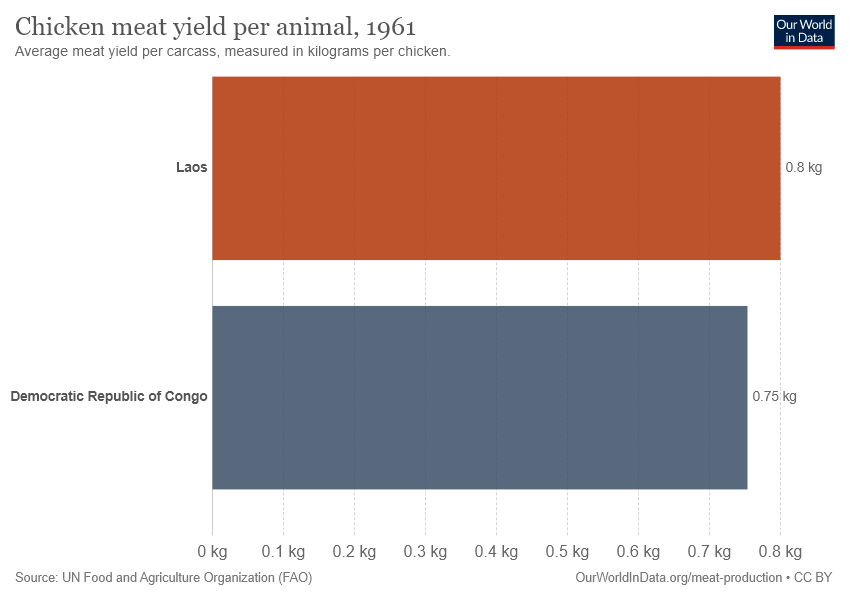Give some essential details in this illustration. The weight of Laos is 0.8. The total weight of both bars is 1.55 kilograms. 